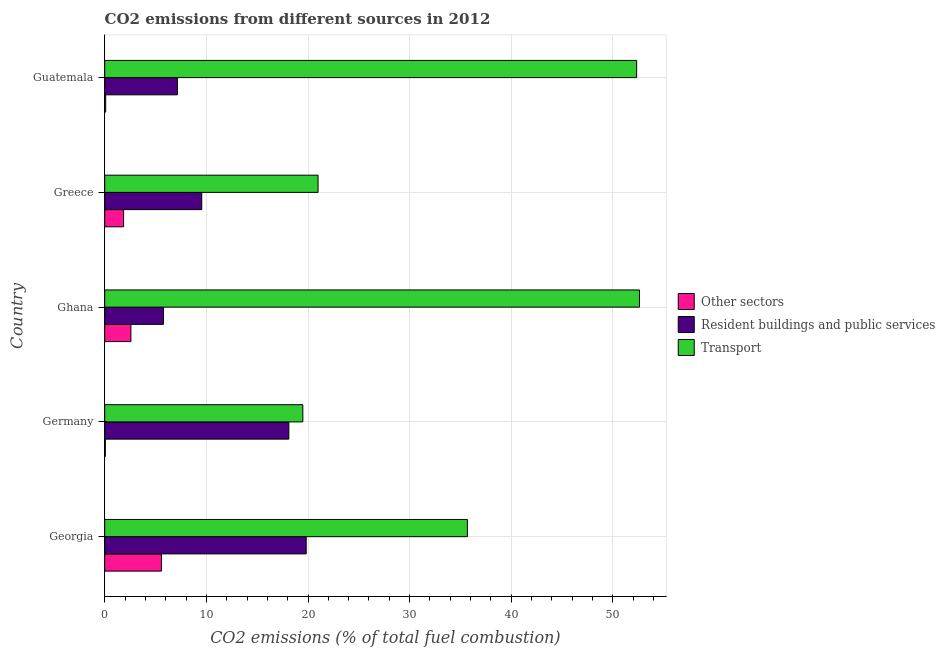How many groups of bars are there?
Your answer should be compact. 5. Are the number of bars on each tick of the Y-axis equal?
Offer a terse response. Yes. What is the label of the 1st group of bars from the top?
Ensure brevity in your answer.  Guatemala. In how many cases, is the number of bars for a given country not equal to the number of legend labels?
Offer a very short reply. 0. What is the percentage of co2 emissions from transport in Germany?
Provide a succinct answer. 19.49. Across all countries, what is the maximum percentage of co2 emissions from transport?
Keep it short and to the point. 52.62. Across all countries, what is the minimum percentage of co2 emissions from other sectors?
Offer a terse response. 0.06. In which country was the percentage of co2 emissions from transport maximum?
Give a very brief answer. Ghana. In which country was the percentage of co2 emissions from resident buildings and public services minimum?
Keep it short and to the point. Ghana. What is the total percentage of co2 emissions from resident buildings and public services in the graph?
Provide a succinct answer. 60.41. What is the difference between the percentage of co2 emissions from other sectors in Germany and that in Greece?
Give a very brief answer. -1.8. What is the difference between the percentage of co2 emissions from resident buildings and public services in Guatemala and the percentage of co2 emissions from other sectors in Georgia?
Offer a very short reply. 1.57. What is the average percentage of co2 emissions from other sectors per country?
Your answer should be very brief. 2.03. What is the difference between the percentage of co2 emissions from transport and percentage of co2 emissions from other sectors in Germany?
Offer a very short reply. 19.43. In how many countries, is the percentage of co2 emissions from resident buildings and public services greater than 4 %?
Give a very brief answer. 5. What is the ratio of the percentage of co2 emissions from transport in Germany to that in Greece?
Offer a terse response. 0.93. Is the percentage of co2 emissions from resident buildings and public services in Georgia less than that in Guatemala?
Offer a terse response. No. Is the difference between the percentage of co2 emissions from other sectors in Germany and Greece greater than the difference between the percentage of co2 emissions from resident buildings and public services in Germany and Greece?
Keep it short and to the point. No. What is the difference between the highest and the second highest percentage of co2 emissions from transport?
Provide a short and direct response. 0.28. What is the difference between the highest and the lowest percentage of co2 emissions from resident buildings and public services?
Ensure brevity in your answer.  14.05. In how many countries, is the percentage of co2 emissions from resident buildings and public services greater than the average percentage of co2 emissions from resident buildings and public services taken over all countries?
Your answer should be very brief. 2. What does the 1st bar from the top in Guatemala represents?
Your response must be concise. Transport. What does the 2nd bar from the bottom in Guatemala represents?
Ensure brevity in your answer.  Resident buildings and public services. How many bars are there?
Your answer should be very brief. 15. What is the difference between two consecutive major ticks on the X-axis?
Offer a very short reply. 10. Are the values on the major ticks of X-axis written in scientific E-notation?
Your response must be concise. No. Does the graph contain grids?
Offer a very short reply. Yes. Where does the legend appear in the graph?
Give a very brief answer. Center right. What is the title of the graph?
Provide a succinct answer. CO2 emissions from different sources in 2012. What is the label or title of the X-axis?
Your answer should be very brief. CO2 emissions (% of total fuel combustion). What is the CO2 emissions (% of total fuel combustion) of Other sectors in Georgia?
Offer a very short reply. 5.58. What is the CO2 emissions (% of total fuel combustion) of Resident buildings and public services in Georgia?
Make the answer very short. 19.82. What is the CO2 emissions (% of total fuel combustion) of Transport in Georgia?
Your answer should be compact. 35.68. What is the CO2 emissions (% of total fuel combustion) of Other sectors in Germany?
Make the answer very short. 0.06. What is the CO2 emissions (% of total fuel combustion) of Resident buildings and public services in Germany?
Offer a terse response. 18.12. What is the CO2 emissions (% of total fuel combustion) in Transport in Germany?
Offer a terse response. 19.49. What is the CO2 emissions (% of total fuel combustion) in Other sectors in Ghana?
Offer a very short reply. 2.58. What is the CO2 emissions (% of total fuel combustion) in Resident buildings and public services in Ghana?
Keep it short and to the point. 5.78. What is the CO2 emissions (% of total fuel combustion) in Transport in Ghana?
Give a very brief answer. 52.62. What is the CO2 emissions (% of total fuel combustion) in Other sectors in Greece?
Your answer should be compact. 1.86. What is the CO2 emissions (% of total fuel combustion) of Resident buildings and public services in Greece?
Keep it short and to the point. 9.55. What is the CO2 emissions (% of total fuel combustion) in Transport in Greece?
Give a very brief answer. 20.99. What is the CO2 emissions (% of total fuel combustion) in Other sectors in Guatemala?
Keep it short and to the point. 0.1. What is the CO2 emissions (% of total fuel combustion) of Resident buildings and public services in Guatemala?
Offer a terse response. 7.15. What is the CO2 emissions (% of total fuel combustion) in Transport in Guatemala?
Your answer should be compact. 52.34. Across all countries, what is the maximum CO2 emissions (% of total fuel combustion) of Other sectors?
Offer a very short reply. 5.58. Across all countries, what is the maximum CO2 emissions (% of total fuel combustion) in Resident buildings and public services?
Make the answer very short. 19.82. Across all countries, what is the maximum CO2 emissions (% of total fuel combustion) in Transport?
Your answer should be very brief. 52.62. Across all countries, what is the minimum CO2 emissions (% of total fuel combustion) of Other sectors?
Keep it short and to the point. 0.06. Across all countries, what is the minimum CO2 emissions (% of total fuel combustion) in Resident buildings and public services?
Provide a short and direct response. 5.78. Across all countries, what is the minimum CO2 emissions (% of total fuel combustion) in Transport?
Your response must be concise. 19.49. What is the total CO2 emissions (% of total fuel combustion) of Other sectors in the graph?
Make the answer very short. 10.17. What is the total CO2 emissions (% of total fuel combustion) of Resident buildings and public services in the graph?
Give a very brief answer. 60.41. What is the total CO2 emissions (% of total fuel combustion) in Transport in the graph?
Your response must be concise. 181.12. What is the difference between the CO2 emissions (% of total fuel combustion) in Other sectors in Georgia and that in Germany?
Offer a very short reply. 5.52. What is the difference between the CO2 emissions (% of total fuel combustion) of Resident buildings and public services in Georgia and that in Germany?
Offer a very short reply. 1.71. What is the difference between the CO2 emissions (% of total fuel combustion) in Transport in Georgia and that in Germany?
Offer a terse response. 16.19. What is the difference between the CO2 emissions (% of total fuel combustion) in Other sectors in Georgia and that in Ghana?
Ensure brevity in your answer.  3. What is the difference between the CO2 emissions (% of total fuel combustion) in Resident buildings and public services in Georgia and that in Ghana?
Provide a short and direct response. 14.05. What is the difference between the CO2 emissions (% of total fuel combustion) of Transport in Georgia and that in Ghana?
Offer a very short reply. -16.93. What is the difference between the CO2 emissions (% of total fuel combustion) in Other sectors in Georgia and that in Greece?
Your answer should be very brief. 3.72. What is the difference between the CO2 emissions (% of total fuel combustion) in Resident buildings and public services in Georgia and that in Greece?
Offer a very short reply. 10.28. What is the difference between the CO2 emissions (% of total fuel combustion) of Transport in Georgia and that in Greece?
Offer a terse response. 14.69. What is the difference between the CO2 emissions (% of total fuel combustion) of Other sectors in Georgia and that in Guatemala?
Offer a terse response. 5.48. What is the difference between the CO2 emissions (% of total fuel combustion) in Resident buildings and public services in Georgia and that in Guatemala?
Provide a succinct answer. 12.67. What is the difference between the CO2 emissions (% of total fuel combustion) in Transport in Georgia and that in Guatemala?
Your answer should be very brief. -16.65. What is the difference between the CO2 emissions (% of total fuel combustion) in Other sectors in Germany and that in Ghana?
Give a very brief answer. -2.51. What is the difference between the CO2 emissions (% of total fuel combustion) in Resident buildings and public services in Germany and that in Ghana?
Provide a short and direct response. 12.34. What is the difference between the CO2 emissions (% of total fuel combustion) of Transport in Germany and that in Ghana?
Ensure brevity in your answer.  -33.12. What is the difference between the CO2 emissions (% of total fuel combustion) of Other sectors in Germany and that in Greece?
Give a very brief answer. -1.8. What is the difference between the CO2 emissions (% of total fuel combustion) of Resident buildings and public services in Germany and that in Greece?
Your answer should be very brief. 8.57. What is the difference between the CO2 emissions (% of total fuel combustion) in Transport in Germany and that in Greece?
Provide a succinct answer. -1.5. What is the difference between the CO2 emissions (% of total fuel combustion) of Other sectors in Germany and that in Guatemala?
Give a very brief answer. -0.03. What is the difference between the CO2 emissions (% of total fuel combustion) in Resident buildings and public services in Germany and that in Guatemala?
Offer a terse response. 10.97. What is the difference between the CO2 emissions (% of total fuel combustion) of Transport in Germany and that in Guatemala?
Provide a short and direct response. -32.84. What is the difference between the CO2 emissions (% of total fuel combustion) of Other sectors in Ghana and that in Greece?
Provide a succinct answer. 0.72. What is the difference between the CO2 emissions (% of total fuel combustion) of Resident buildings and public services in Ghana and that in Greece?
Keep it short and to the point. -3.77. What is the difference between the CO2 emissions (% of total fuel combustion) of Transport in Ghana and that in Greece?
Your answer should be very brief. 31.62. What is the difference between the CO2 emissions (% of total fuel combustion) in Other sectors in Ghana and that in Guatemala?
Provide a succinct answer. 2.48. What is the difference between the CO2 emissions (% of total fuel combustion) of Resident buildings and public services in Ghana and that in Guatemala?
Offer a very short reply. -1.37. What is the difference between the CO2 emissions (% of total fuel combustion) in Transport in Ghana and that in Guatemala?
Give a very brief answer. 0.28. What is the difference between the CO2 emissions (% of total fuel combustion) in Other sectors in Greece and that in Guatemala?
Give a very brief answer. 1.76. What is the difference between the CO2 emissions (% of total fuel combustion) of Resident buildings and public services in Greece and that in Guatemala?
Your answer should be very brief. 2.4. What is the difference between the CO2 emissions (% of total fuel combustion) of Transport in Greece and that in Guatemala?
Keep it short and to the point. -31.34. What is the difference between the CO2 emissions (% of total fuel combustion) of Other sectors in Georgia and the CO2 emissions (% of total fuel combustion) of Resident buildings and public services in Germany?
Offer a terse response. -12.54. What is the difference between the CO2 emissions (% of total fuel combustion) of Other sectors in Georgia and the CO2 emissions (% of total fuel combustion) of Transport in Germany?
Your answer should be compact. -13.91. What is the difference between the CO2 emissions (% of total fuel combustion) of Resident buildings and public services in Georgia and the CO2 emissions (% of total fuel combustion) of Transport in Germany?
Offer a very short reply. 0.33. What is the difference between the CO2 emissions (% of total fuel combustion) in Other sectors in Georgia and the CO2 emissions (% of total fuel combustion) in Resident buildings and public services in Ghana?
Your answer should be compact. -0.2. What is the difference between the CO2 emissions (% of total fuel combustion) in Other sectors in Georgia and the CO2 emissions (% of total fuel combustion) in Transport in Ghana?
Provide a succinct answer. -47.04. What is the difference between the CO2 emissions (% of total fuel combustion) in Resident buildings and public services in Georgia and the CO2 emissions (% of total fuel combustion) in Transport in Ghana?
Your response must be concise. -32.79. What is the difference between the CO2 emissions (% of total fuel combustion) in Other sectors in Georgia and the CO2 emissions (% of total fuel combustion) in Resident buildings and public services in Greece?
Provide a short and direct response. -3.97. What is the difference between the CO2 emissions (% of total fuel combustion) in Other sectors in Georgia and the CO2 emissions (% of total fuel combustion) in Transport in Greece?
Ensure brevity in your answer.  -15.41. What is the difference between the CO2 emissions (% of total fuel combustion) in Resident buildings and public services in Georgia and the CO2 emissions (% of total fuel combustion) in Transport in Greece?
Make the answer very short. -1.17. What is the difference between the CO2 emissions (% of total fuel combustion) of Other sectors in Georgia and the CO2 emissions (% of total fuel combustion) of Resident buildings and public services in Guatemala?
Provide a succinct answer. -1.57. What is the difference between the CO2 emissions (% of total fuel combustion) in Other sectors in Georgia and the CO2 emissions (% of total fuel combustion) in Transport in Guatemala?
Offer a very short reply. -46.76. What is the difference between the CO2 emissions (% of total fuel combustion) in Resident buildings and public services in Georgia and the CO2 emissions (% of total fuel combustion) in Transport in Guatemala?
Keep it short and to the point. -32.51. What is the difference between the CO2 emissions (% of total fuel combustion) of Other sectors in Germany and the CO2 emissions (% of total fuel combustion) of Resident buildings and public services in Ghana?
Your answer should be very brief. -5.71. What is the difference between the CO2 emissions (% of total fuel combustion) of Other sectors in Germany and the CO2 emissions (% of total fuel combustion) of Transport in Ghana?
Your answer should be very brief. -52.55. What is the difference between the CO2 emissions (% of total fuel combustion) of Resident buildings and public services in Germany and the CO2 emissions (% of total fuel combustion) of Transport in Ghana?
Provide a short and direct response. -34.5. What is the difference between the CO2 emissions (% of total fuel combustion) in Other sectors in Germany and the CO2 emissions (% of total fuel combustion) in Resident buildings and public services in Greece?
Give a very brief answer. -9.48. What is the difference between the CO2 emissions (% of total fuel combustion) in Other sectors in Germany and the CO2 emissions (% of total fuel combustion) in Transport in Greece?
Ensure brevity in your answer.  -20.93. What is the difference between the CO2 emissions (% of total fuel combustion) in Resident buildings and public services in Germany and the CO2 emissions (% of total fuel combustion) in Transport in Greece?
Your response must be concise. -2.88. What is the difference between the CO2 emissions (% of total fuel combustion) in Other sectors in Germany and the CO2 emissions (% of total fuel combustion) in Resident buildings and public services in Guatemala?
Keep it short and to the point. -7.09. What is the difference between the CO2 emissions (% of total fuel combustion) in Other sectors in Germany and the CO2 emissions (% of total fuel combustion) in Transport in Guatemala?
Offer a terse response. -52.27. What is the difference between the CO2 emissions (% of total fuel combustion) in Resident buildings and public services in Germany and the CO2 emissions (% of total fuel combustion) in Transport in Guatemala?
Your answer should be compact. -34.22. What is the difference between the CO2 emissions (% of total fuel combustion) of Other sectors in Ghana and the CO2 emissions (% of total fuel combustion) of Resident buildings and public services in Greece?
Provide a short and direct response. -6.97. What is the difference between the CO2 emissions (% of total fuel combustion) in Other sectors in Ghana and the CO2 emissions (% of total fuel combustion) in Transport in Greece?
Your answer should be very brief. -18.41. What is the difference between the CO2 emissions (% of total fuel combustion) in Resident buildings and public services in Ghana and the CO2 emissions (% of total fuel combustion) in Transport in Greece?
Keep it short and to the point. -15.21. What is the difference between the CO2 emissions (% of total fuel combustion) in Other sectors in Ghana and the CO2 emissions (% of total fuel combustion) in Resident buildings and public services in Guatemala?
Your answer should be compact. -4.57. What is the difference between the CO2 emissions (% of total fuel combustion) in Other sectors in Ghana and the CO2 emissions (% of total fuel combustion) in Transport in Guatemala?
Make the answer very short. -49.76. What is the difference between the CO2 emissions (% of total fuel combustion) in Resident buildings and public services in Ghana and the CO2 emissions (% of total fuel combustion) in Transport in Guatemala?
Give a very brief answer. -46.56. What is the difference between the CO2 emissions (% of total fuel combustion) in Other sectors in Greece and the CO2 emissions (% of total fuel combustion) in Resident buildings and public services in Guatemala?
Your answer should be very brief. -5.29. What is the difference between the CO2 emissions (% of total fuel combustion) in Other sectors in Greece and the CO2 emissions (% of total fuel combustion) in Transport in Guatemala?
Offer a terse response. -50.48. What is the difference between the CO2 emissions (% of total fuel combustion) in Resident buildings and public services in Greece and the CO2 emissions (% of total fuel combustion) in Transport in Guatemala?
Your answer should be compact. -42.79. What is the average CO2 emissions (% of total fuel combustion) in Other sectors per country?
Your response must be concise. 2.03. What is the average CO2 emissions (% of total fuel combustion) of Resident buildings and public services per country?
Your answer should be compact. 12.08. What is the average CO2 emissions (% of total fuel combustion) of Transport per country?
Provide a short and direct response. 36.22. What is the difference between the CO2 emissions (% of total fuel combustion) of Other sectors and CO2 emissions (% of total fuel combustion) of Resident buildings and public services in Georgia?
Your answer should be compact. -14.24. What is the difference between the CO2 emissions (% of total fuel combustion) in Other sectors and CO2 emissions (% of total fuel combustion) in Transport in Georgia?
Your answer should be very brief. -30.1. What is the difference between the CO2 emissions (% of total fuel combustion) in Resident buildings and public services and CO2 emissions (% of total fuel combustion) in Transport in Georgia?
Provide a short and direct response. -15.86. What is the difference between the CO2 emissions (% of total fuel combustion) of Other sectors and CO2 emissions (% of total fuel combustion) of Resident buildings and public services in Germany?
Keep it short and to the point. -18.05. What is the difference between the CO2 emissions (% of total fuel combustion) of Other sectors and CO2 emissions (% of total fuel combustion) of Transport in Germany?
Your response must be concise. -19.43. What is the difference between the CO2 emissions (% of total fuel combustion) in Resident buildings and public services and CO2 emissions (% of total fuel combustion) in Transport in Germany?
Give a very brief answer. -1.38. What is the difference between the CO2 emissions (% of total fuel combustion) of Other sectors and CO2 emissions (% of total fuel combustion) of Resident buildings and public services in Ghana?
Keep it short and to the point. -3.2. What is the difference between the CO2 emissions (% of total fuel combustion) of Other sectors and CO2 emissions (% of total fuel combustion) of Transport in Ghana?
Ensure brevity in your answer.  -50.04. What is the difference between the CO2 emissions (% of total fuel combustion) of Resident buildings and public services and CO2 emissions (% of total fuel combustion) of Transport in Ghana?
Your response must be concise. -46.84. What is the difference between the CO2 emissions (% of total fuel combustion) of Other sectors and CO2 emissions (% of total fuel combustion) of Resident buildings and public services in Greece?
Give a very brief answer. -7.69. What is the difference between the CO2 emissions (% of total fuel combustion) in Other sectors and CO2 emissions (% of total fuel combustion) in Transport in Greece?
Keep it short and to the point. -19.13. What is the difference between the CO2 emissions (% of total fuel combustion) in Resident buildings and public services and CO2 emissions (% of total fuel combustion) in Transport in Greece?
Your response must be concise. -11.44. What is the difference between the CO2 emissions (% of total fuel combustion) of Other sectors and CO2 emissions (% of total fuel combustion) of Resident buildings and public services in Guatemala?
Make the answer very short. -7.05. What is the difference between the CO2 emissions (% of total fuel combustion) of Other sectors and CO2 emissions (% of total fuel combustion) of Transport in Guatemala?
Your response must be concise. -52.24. What is the difference between the CO2 emissions (% of total fuel combustion) of Resident buildings and public services and CO2 emissions (% of total fuel combustion) of Transport in Guatemala?
Offer a very short reply. -45.19. What is the ratio of the CO2 emissions (% of total fuel combustion) in Other sectors in Georgia to that in Germany?
Ensure brevity in your answer.  89.67. What is the ratio of the CO2 emissions (% of total fuel combustion) of Resident buildings and public services in Georgia to that in Germany?
Your response must be concise. 1.09. What is the ratio of the CO2 emissions (% of total fuel combustion) in Transport in Georgia to that in Germany?
Give a very brief answer. 1.83. What is the ratio of the CO2 emissions (% of total fuel combustion) of Other sectors in Georgia to that in Ghana?
Your answer should be very brief. 2.17. What is the ratio of the CO2 emissions (% of total fuel combustion) in Resident buildings and public services in Georgia to that in Ghana?
Offer a very short reply. 3.43. What is the ratio of the CO2 emissions (% of total fuel combustion) of Transport in Georgia to that in Ghana?
Provide a short and direct response. 0.68. What is the ratio of the CO2 emissions (% of total fuel combustion) of Other sectors in Georgia to that in Greece?
Make the answer very short. 3. What is the ratio of the CO2 emissions (% of total fuel combustion) in Resident buildings and public services in Georgia to that in Greece?
Keep it short and to the point. 2.08. What is the ratio of the CO2 emissions (% of total fuel combustion) in Transport in Georgia to that in Greece?
Your answer should be compact. 1.7. What is the ratio of the CO2 emissions (% of total fuel combustion) of Other sectors in Georgia to that in Guatemala?
Provide a short and direct response. 58.53. What is the ratio of the CO2 emissions (% of total fuel combustion) in Resident buildings and public services in Georgia to that in Guatemala?
Offer a terse response. 2.77. What is the ratio of the CO2 emissions (% of total fuel combustion) in Transport in Georgia to that in Guatemala?
Your response must be concise. 0.68. What is the ratio of the CO2 emissions (% of total fuel combustion) of Other sectors in Germany to that in Ghana?
Your answer should be very brief. 0.02. What is the ratio of the CO2 emissions (% of total fuel combustion) in Resident buildings and public services in Germany to that in Ghana?
Give a very brief answer. 3.14. What is the ratio of the CO2 emissions (% of total fuel combustion) in Transport in Germany to that in Ghana?
Give a very brief answer. 0.37. What is the ratio of the CO2 emissions (% of total fuel combustion) in Other sectors in Germany to that in Greece?
Ensure brevity in your answer.  0.03. What is the ratio of the CO2 emissions (% of total fuel combustion) of Resident buildings and public services in Germany to that in Greece?
Provide a short and direct response. 1.9. What is the ratio of the CO2 emissions (% of total fuel combustion) in Transport in Germany to that in Greece?
Give a very brief answer. 0.93. What is the ratio of the CO2 emissions (% of total fuel combustion) in Other sectors in Germany to that in Guatemala?
Give a very brief answer. 0.65. What is the ratio of the CO2 emissions (% of total fuel combustion) in Resident buildings and public services in Germany to that in Guatemala?
Your answer should be compact. 2.53. What is the ratio of the CO2 emissions (% of total fuel combustion) in Transport in Germany to that in Guatemala?
Your response must be concise. 0.37. What is the ratio of the CO2 emissions (% of total fuel combustion) of Other sectors in Ghana to that in Greece?
Offer a very short reply. 1.39. What is the ratio of the CO2 emissions (% of total fuel combustion) of Resident buildings and public services in Ghana to that in Greece?
Your answer should be compact. 0.61. What is the ratio of the CO2 emissions (% of total fuel combustion) of Transport in Ghana to that in Greece?
Your response must be concise. 2.51. What is the ratio of the CO2 emissions (% of total fuel combustion) in Other sectors in Ghana to that in Guatemala?
Provide a succinct answer. 27.02. What is the ratio of the CO2 emissions (% of total fuel combustion) of Resident buildings and public services in Ghana to that in Guatemala?
Ensure brevity in your answer.  0.81. What is the ratio of the CO2 emissions (% of total fuel combustion) of Other sectors in Greece to that in Guatemala?
Ensure brevity in your answer.  19.49. What is the ratio of the CO2 emissions (% of total fuel combustion) of Resident buildings and public services in Greece to that in Guatemala?
Ensure brevity in your answer.  1.34. What is the ratio of the CO2 emissions (% of total fuel combustion) of Transport in Greece to that in Guatemala?
Offer a very short reply. 0.4. What is the difference between the highest and the second highest CO2 emissions (% of total fuel combustion) in Other sectors?
Ensure brevity in your answer.  3. What is the difference between the highest and the second highest CO2 emissions (% of total fuel combustion) of Resident buildings and public services?
Offer a very short reply. 1.71. What is the difference between the highest and the second highest CO2 emissions (% of total fuel combustion) in Transport?
Offer a very short reply. 0.28. What is the difference between the highest and the lowest CO2 emissions (% of total fuel combustion) of Other sectors?
Keep it short and to the point. 5.52. What is the difference between the highest and the lowest CO2 emissions (% of total fuel combustion) of Resident buildings and public services?
Keep it short and to the point. 14.05. What is the difference between the highest and the lowest CO2 emissions (% of total fuel combustion) of Transport?
Provide a succinct answer. 33.12. 